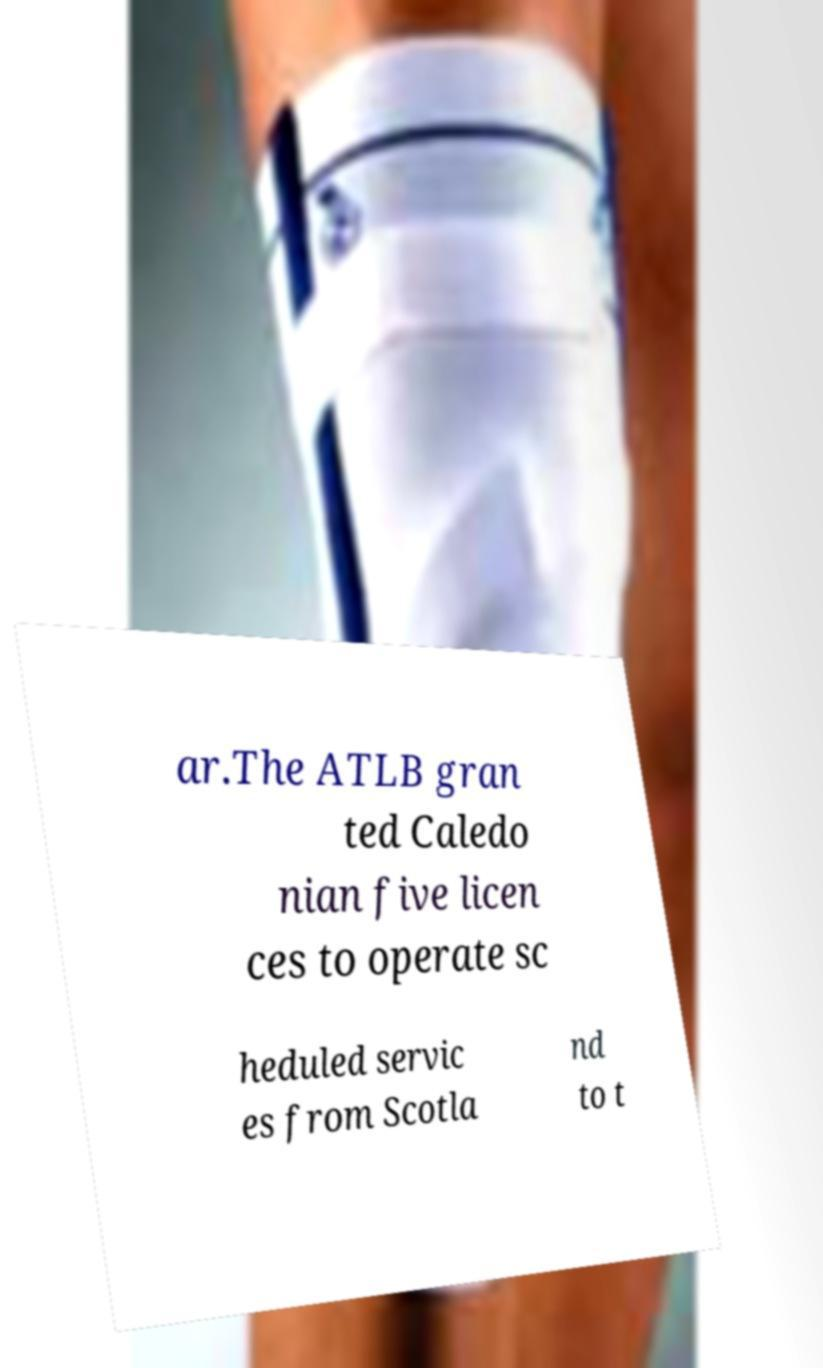For documentation purposes, I need the text within this image transcribed. Could you provide that? ar.The ATLB gran ted Caledo nian five licen ces to operate sc heduled servic es from Scotla nd to t 